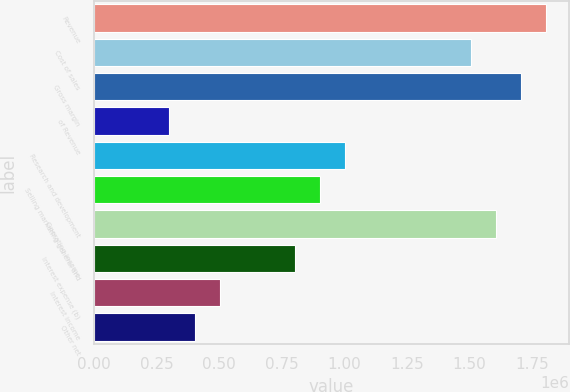Convert chart. <chart><loc_0><loc_0><loc_500><loc_500><bar_chart><fcel>Revenue<fcel>Cost of sales<fcel>Gross margin<fcel>of Revenue<fcel>Research and development<fcel>Selling marketing general and<fcel>Operating income<fcel>Interest expense (b)<fcel>Interest income<fcel>Other net<nl><fcel>1.80652e+06<fcel>1.50543e+06<fcel>1.70616e+06<fcel>301087<fcel>1.00362e+06<fcel>903261<fcel>1.6058e+06<fcel>802898<fcel>501812<fcel>401449<nl></chart> 